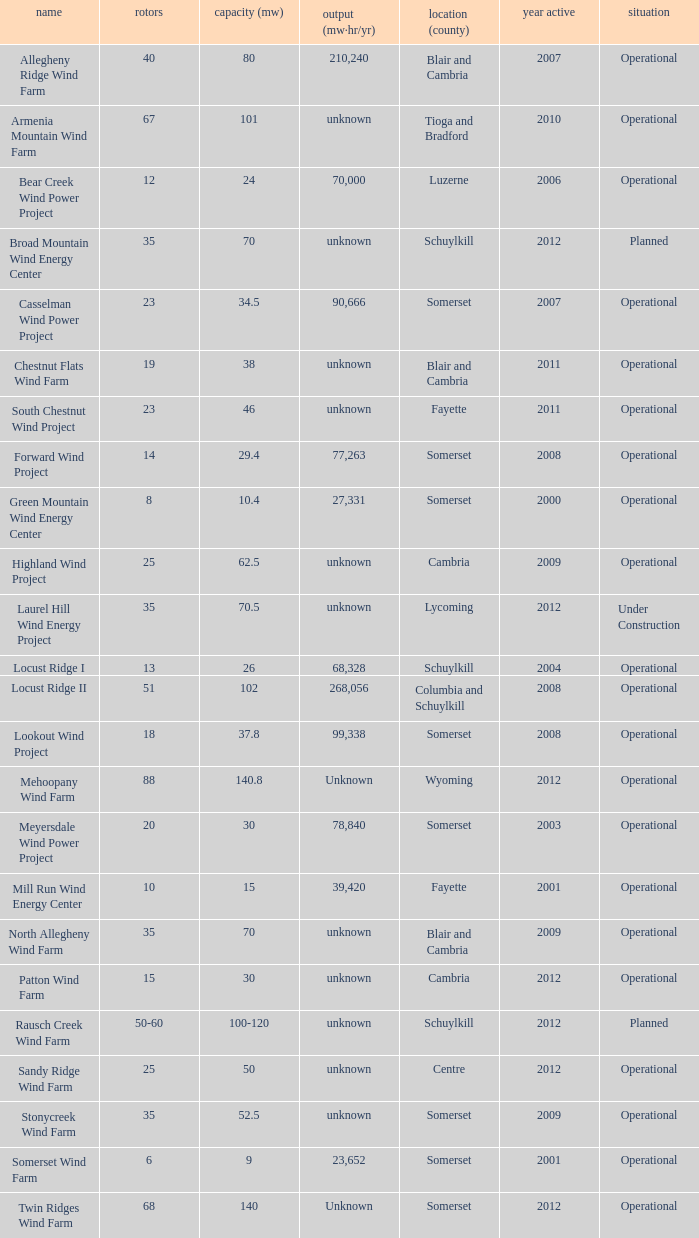What all capacities have turbines between 50-60? 100-120. 